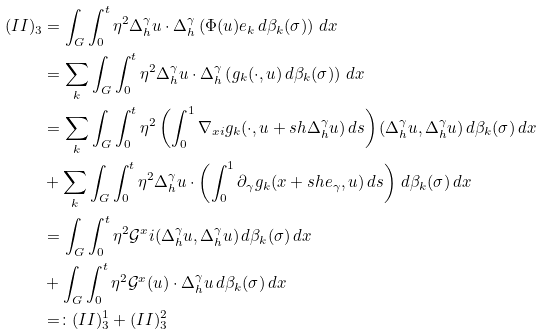Convert formula to latex. <formula><loc_0><loc_0><loc_500><loc_500>( I I ) _ { 3 } & = \int _ { G } \int _ { 0 } ^ { t } \eta ^ { 2 } \Delta _ { h } ^ { \gamma } u \cdot \Delta _ { h } ^ { \gamma } \left ( \Phi ( u ) e _ { k } \, d \beta _ { k } ( \sigma ) \right ) \, d x \\ & = \sum _ { k } \int _ { G } \int _ { 0 } ^ { t } \eta ^ { 2 } \Delta _ { h } ^ { \gamma } u \cdot \Delta _ { h } ^ { \gamma } \left ( g _ { k } ( \cdot , u ) \, d \beta _ { k } ( \sigma ) \right ) \, d x \\ & = \sum _ { k } \int _ { G } \int _ { 0 } ^ { t } \eta ^ { 2 } \left ( \int _ { 0 } ^ { 1 } \nabla _ { x i } g _ { k } ( \cdot , u + s h \Delta _ { h } ^ { \gamma } u ) \, d s \right ) ( \Delta _ { h } ^ { \gamma } u , \Delta _ { h } ^ { \gamma } u ) \, d \beta _ { k } ( \sigma ) \, d x \\ & + \sum _ { k } \int _ { G } \int _ { 0 } ^ { t } \eta ^ { 2 } \Delta _ { h } ^ { \gamma } u \cdot \left ( \int _ { 0 } ^ { 1 } \partial _ { \gamma } g _ { k } ( x + s h e _ { \gamma } , u ) \, d s \right ) \, d \beta _ { k } ( \sigma ) \, d x \\ & = \int _ { G } \int _ { 0 } ^ { t } \eta ^ { 2 } \mathcal { G } ^ { x } i ( \Delta _ { h } ^ { \gamma } u , \Delta _ { h } ^ { \gamma } u ) \, d \beta _ { k } ( \sigma ) \, d x \\ & + \int _ { G } \int _ { 0 } ^ { t } \eta ^ { 2 } \mathcal { G } ^ { x } ( u ) \cdot \Delta _ { h } ^ { \gamma } u \, d \beta _ { k } ( \sigma ) \, d x \\ & = \colon ( I I ) _ { 3 } ^ { 1 } + ( I I ) _ { 3 } ^ { 2 }</formula> 